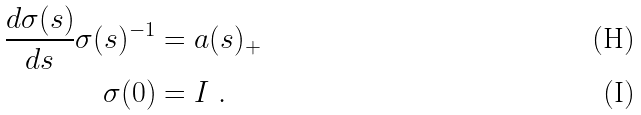<formula> <loc_0><loc_0><loc_500><loc_500>\frac { d \sigma ( s ) } { d s } \sigma ( s ) ^ { - 1 } & = a ( s ) _ { + } \\ \sigma ( 0 ) & = I \ .</formula> 